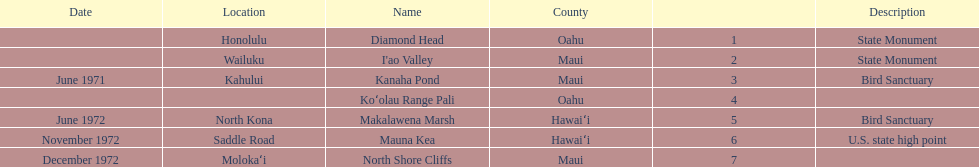What is the overall count of landmarks situated in maui? 3. 